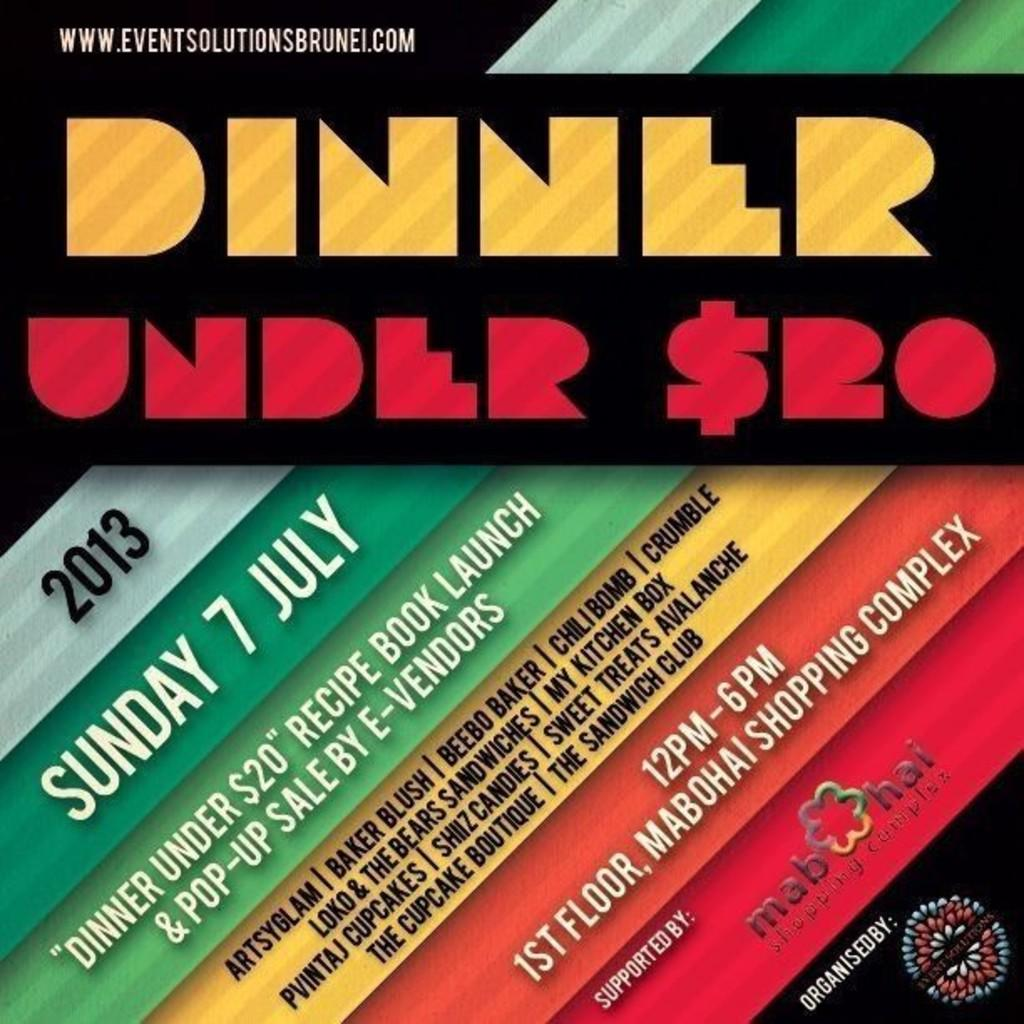Provide a one-sentence caption for the provided image. The year being shown to the left is 2013. 